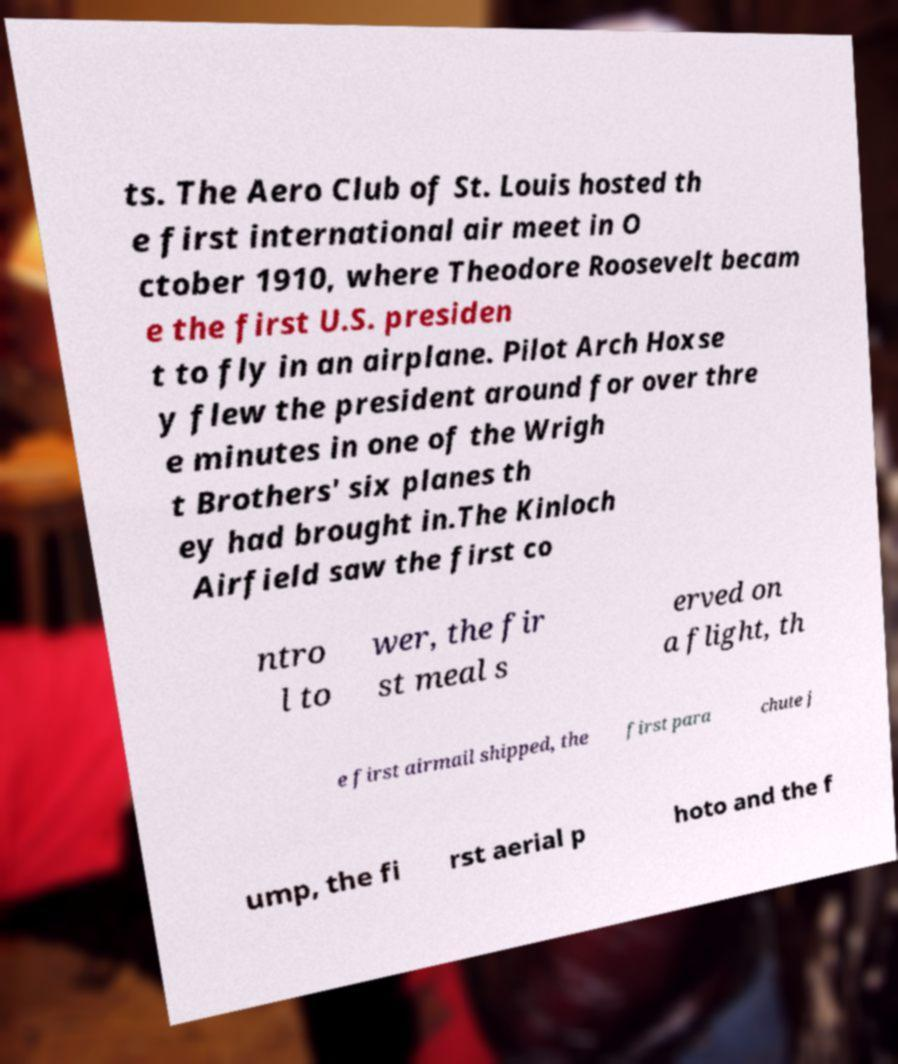Could you extract and type out the text from this image? ts. The Aero Club of St. Louis hosted th e first international air meet in O ctober 1910, where Theodore Roosevelt becam e the first U.S. presiden t to fly in an airplane. Pilot Arch Hoxse y flew the president around for over thre e minutes in one of the Wrigh t Brothers' six planes th ey had brought in.The Kinloch Airfield saw the first co ntro l to wer, the fir st meal s erved on a flight, th e first airmail shipped, the first para chute j ump, the fi rst aerial p hoto and the f 